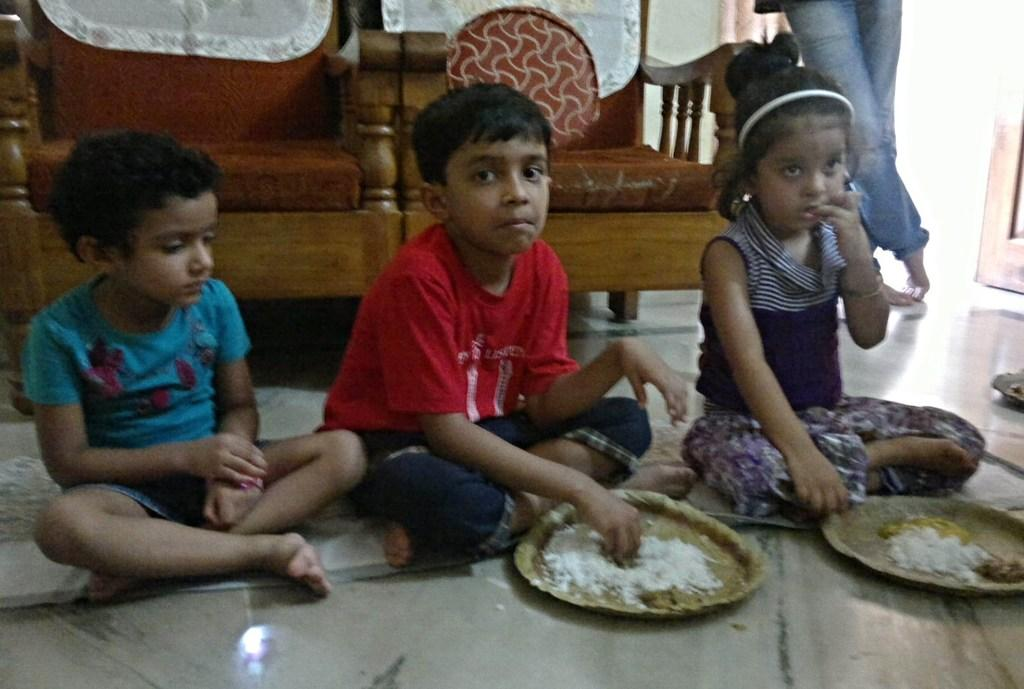How many children are in the image? There are three children in the image. What are the children doing in the image? The children are sitting on the floor. What is in front of the children? There are plates with food in front of the children. What can be seen in the background of the image? There are chairs visible in the background of the image, and there is a person standing in the background. What type of cord is being used by the children to play with the butter in the image? There is no cord or butter present in the image; the children are sitting with plates of food in front of them. 